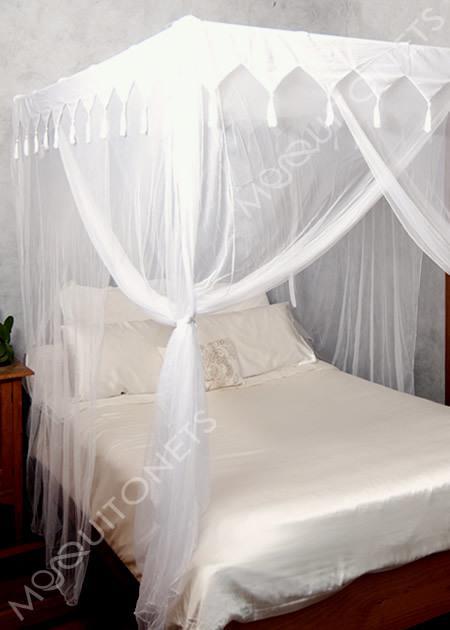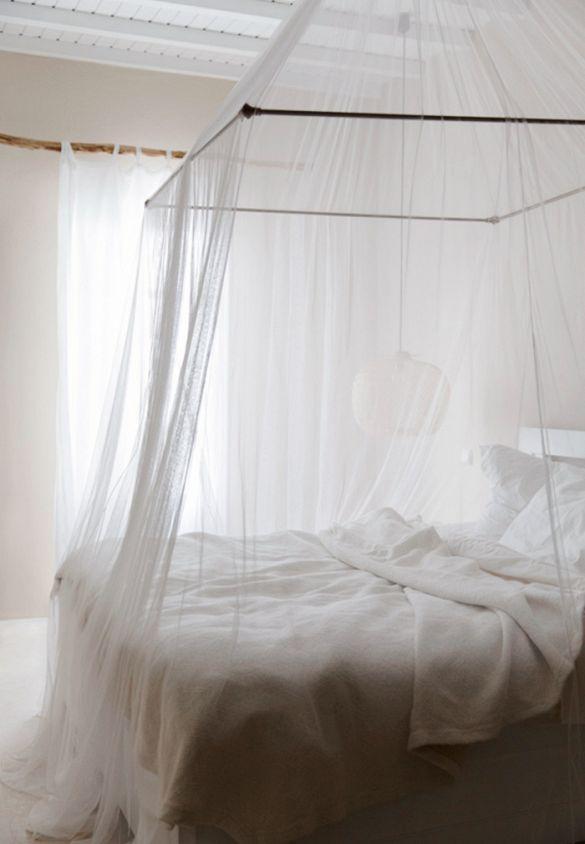The first image is the image on the left, the second image is the image on the right. For the images displayed, is the sentence "The drapery of one bed frames it as a four poster with a top ruffle, while the other bed drapery falls from a central point above the bed." factually correct? Answer yes or no. Yes. The first image is the image on the left, the second image is the image on the right. Assess this claim about the two images: "An image shows a ceiling-suspended tent-shaped netting bed canopy.". Correct or not? Answer yes or no. Yes. 